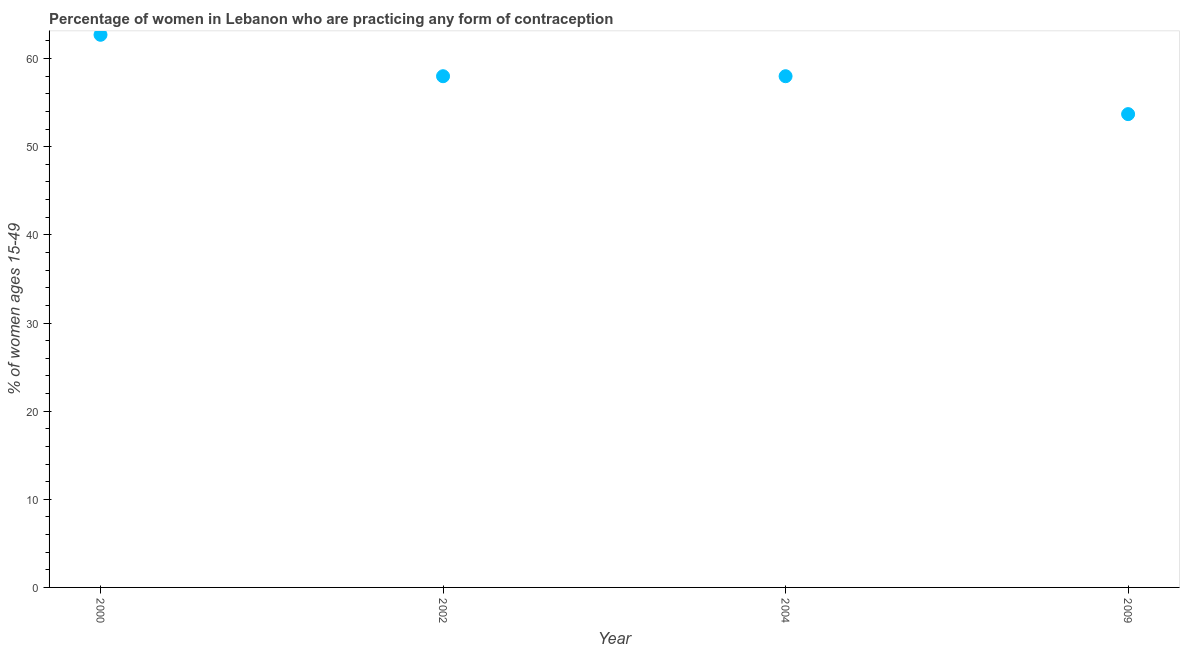What is the contraceptive prevalence in 2009?
Offer a terse response. 53.7. Across all years, what is the maximum contraceptive prevalence?
Give a very brief answer. 62.7. Across all years, what is the minimum contraceptive prevalence?
Offer a very short reply. 53.7. In which year was the contraceptive prevalence maximum?
Keep it short and to the point. 2000. What is the sum of the contraceptive prevalence?
Your answer should be very brief. 232.4. What is the difference between the contraceptive prevalence in 2000 and 2002?
Your answer should be very brief. 4.7. What is the average contraceptive prevalence per year?
Offer a very short reply. 58.1. In how many years, is the contraceptive prevalence greater than 30 %?
Provide a short and direct response. 4. Do a majority of the years between 2000 and 2004 (inclusive) have contraceptive prevalence greater than 10 %?
Your answer should be compact. Yes. What is the ratio of the contraceptive prevalence in 2000 to that in 2002?
Make the answer very short. 1.08. Is the difference between the contraceptive prevalence in 2004 and 2009 greater than the difference between any two years?
Give a very brief answer. No. What is the difference between the highest and the second highest contraceptive prevalence?
Your answer should be compact. 4.7. What is the difference between the highest and the lowest contraceptive prevalence?
Give a very brief answer. 9. In how many years, is the contraceptive prevalence greater than the average contraceptive prevalence taken over all years?
Your answer should be compact. 1. How many years are there in the graph?
Your answer should be compact. 4. Are the values on the major ticks of Y-axis written in scientific E-notation?
Your answer should be very brief. No. Does the graph contain any zero values?
Your answer should be very brief. No. Does the graph contain grids?
Make the answer very short. No. What is the title of the graph?
Make the answer very short. Percentage of women in Lebanon who are practicing any form of contraception. What is the label or title of the Y-axis?
Provide a succinct answer. % of women ages 15-49. What is the % of women ages 15-49 in 2000?
Your answer should be compact. 62.7. What is the % of women ages 15-49 in 2002?
Offer a terse response. 58. What is the % of women ages 15-49 in 2004?
Your answer should be very brief. 58. What is the % of women ages 15-49 in 2009?
Your answer should be compact. 53.7. What is the difference between the % of women ages 15-49 in 2000 and 2004?
Ensure brevity in your answer.  4.7. What is the difference between the % of women ages 15-49 in 2000 and 2009?
Keep it short and to the point. 9. What is the ratio of the % of women ages 15-49 in 2000 to that in 2002?
Offer a terse response. 1.08. What is the ratio of the % of women ages 15-49 in 2000 to that in 2004?
Offer a very short reply. 1.08. What is the ratio of the % of women ages 15-49 in 2000 to that in 2009?
Offer a terse response. 1.17. What is the ratio of the % of women ages 15-49 in 2002 to that in 2004?
Ensure brevity in your answer.  1. What is the ratio of the % of women ages 15-49 in 2002 to that in 2009?
Your answer should be compact. 1.08. 